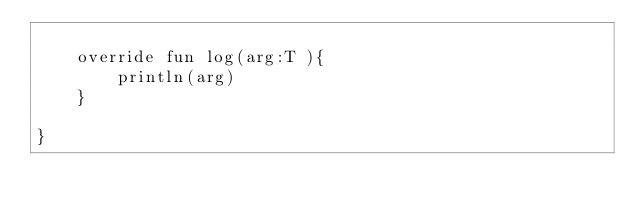<code> <loc_0><loc_0><loc_500><loc_500><_Kotlin_>
    override fun log(arg:T ){
        println(arg)
    }

}</code> 